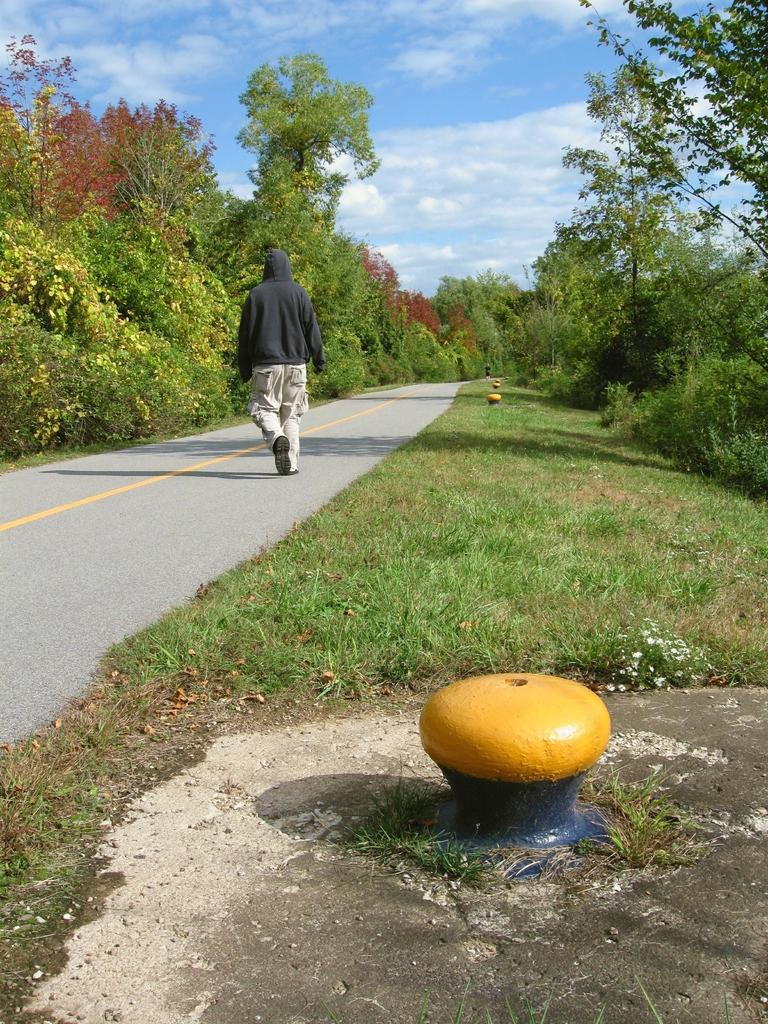What is the main subject of the image? There is a person walking on the road in the image. What color can be seen in the image? There are yellow color objects in the image. What type of vegetation is visible in the image? The grass, plants, and trees are visible in the image. What part of the natural environment is visible in the image? The sky is visible in the image. How many bats are hanging from the trees in the image? There are no bats present in the image; only the person walking on the road, yellow objects, grass, plants, trees, and the sky are visible. What type of beds can be seen in the image? There are no beds present in the image. 